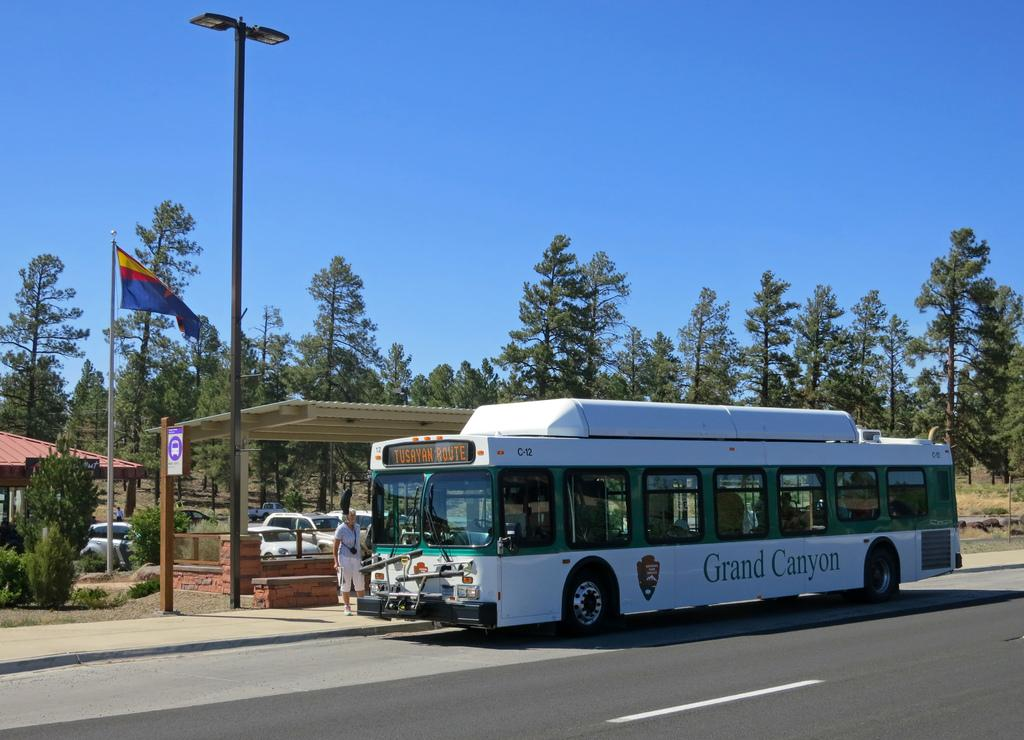What types of objects can be seen in the image? There are vehicles, poles, plants, trees, a board, a flag, sheds, and a road visible in the image. What is the purpose of the poles in the image? The purpose of the poles is not explicitly stated, but they may be used for supporting wires or signs. What type of vegetation is present in the image? Both plants and trees are present in the image. What is attached to the board in the image? The flag is attached to the board in the image. What is the condition of the sky in the background of the image? The sky is visible in the background of the image, but its condition (e.g., clear, cloudy) is not specified. How does the thumb help the quicksand in the image? There is no thumb or quicksand present in the image, so this question cannot be answered. 